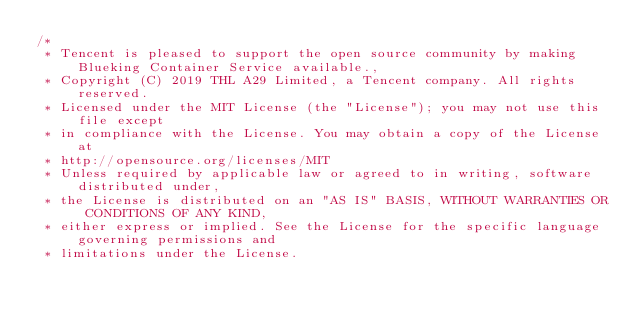<code> <loc_0><loc_0><loc_500><loc_500><_Go_>/*
 * Tencent is pleased to support the open source community by making Blueking Container Service available.,
 * Copyright (C) 2019 THL A29 Limited, a Tencent company. All rights reserved.
 * Licensed under the MIT License (the "License"); you may not use this file except
 * in compliance with the License. You may obtain a copy of the License at
 * http://opensource.org/licenses/MIT
 * Unless required by applicable law or agreed to in writing, software distributed under,
 * the License is distributed on an "AS IS" BASIS, WITHOUT WARRANTIES OR CONDITIONS OF ANY KIND,
 * either express or implied. See the License for the specific language governing permissions and
 * limitations under the License.</code> 